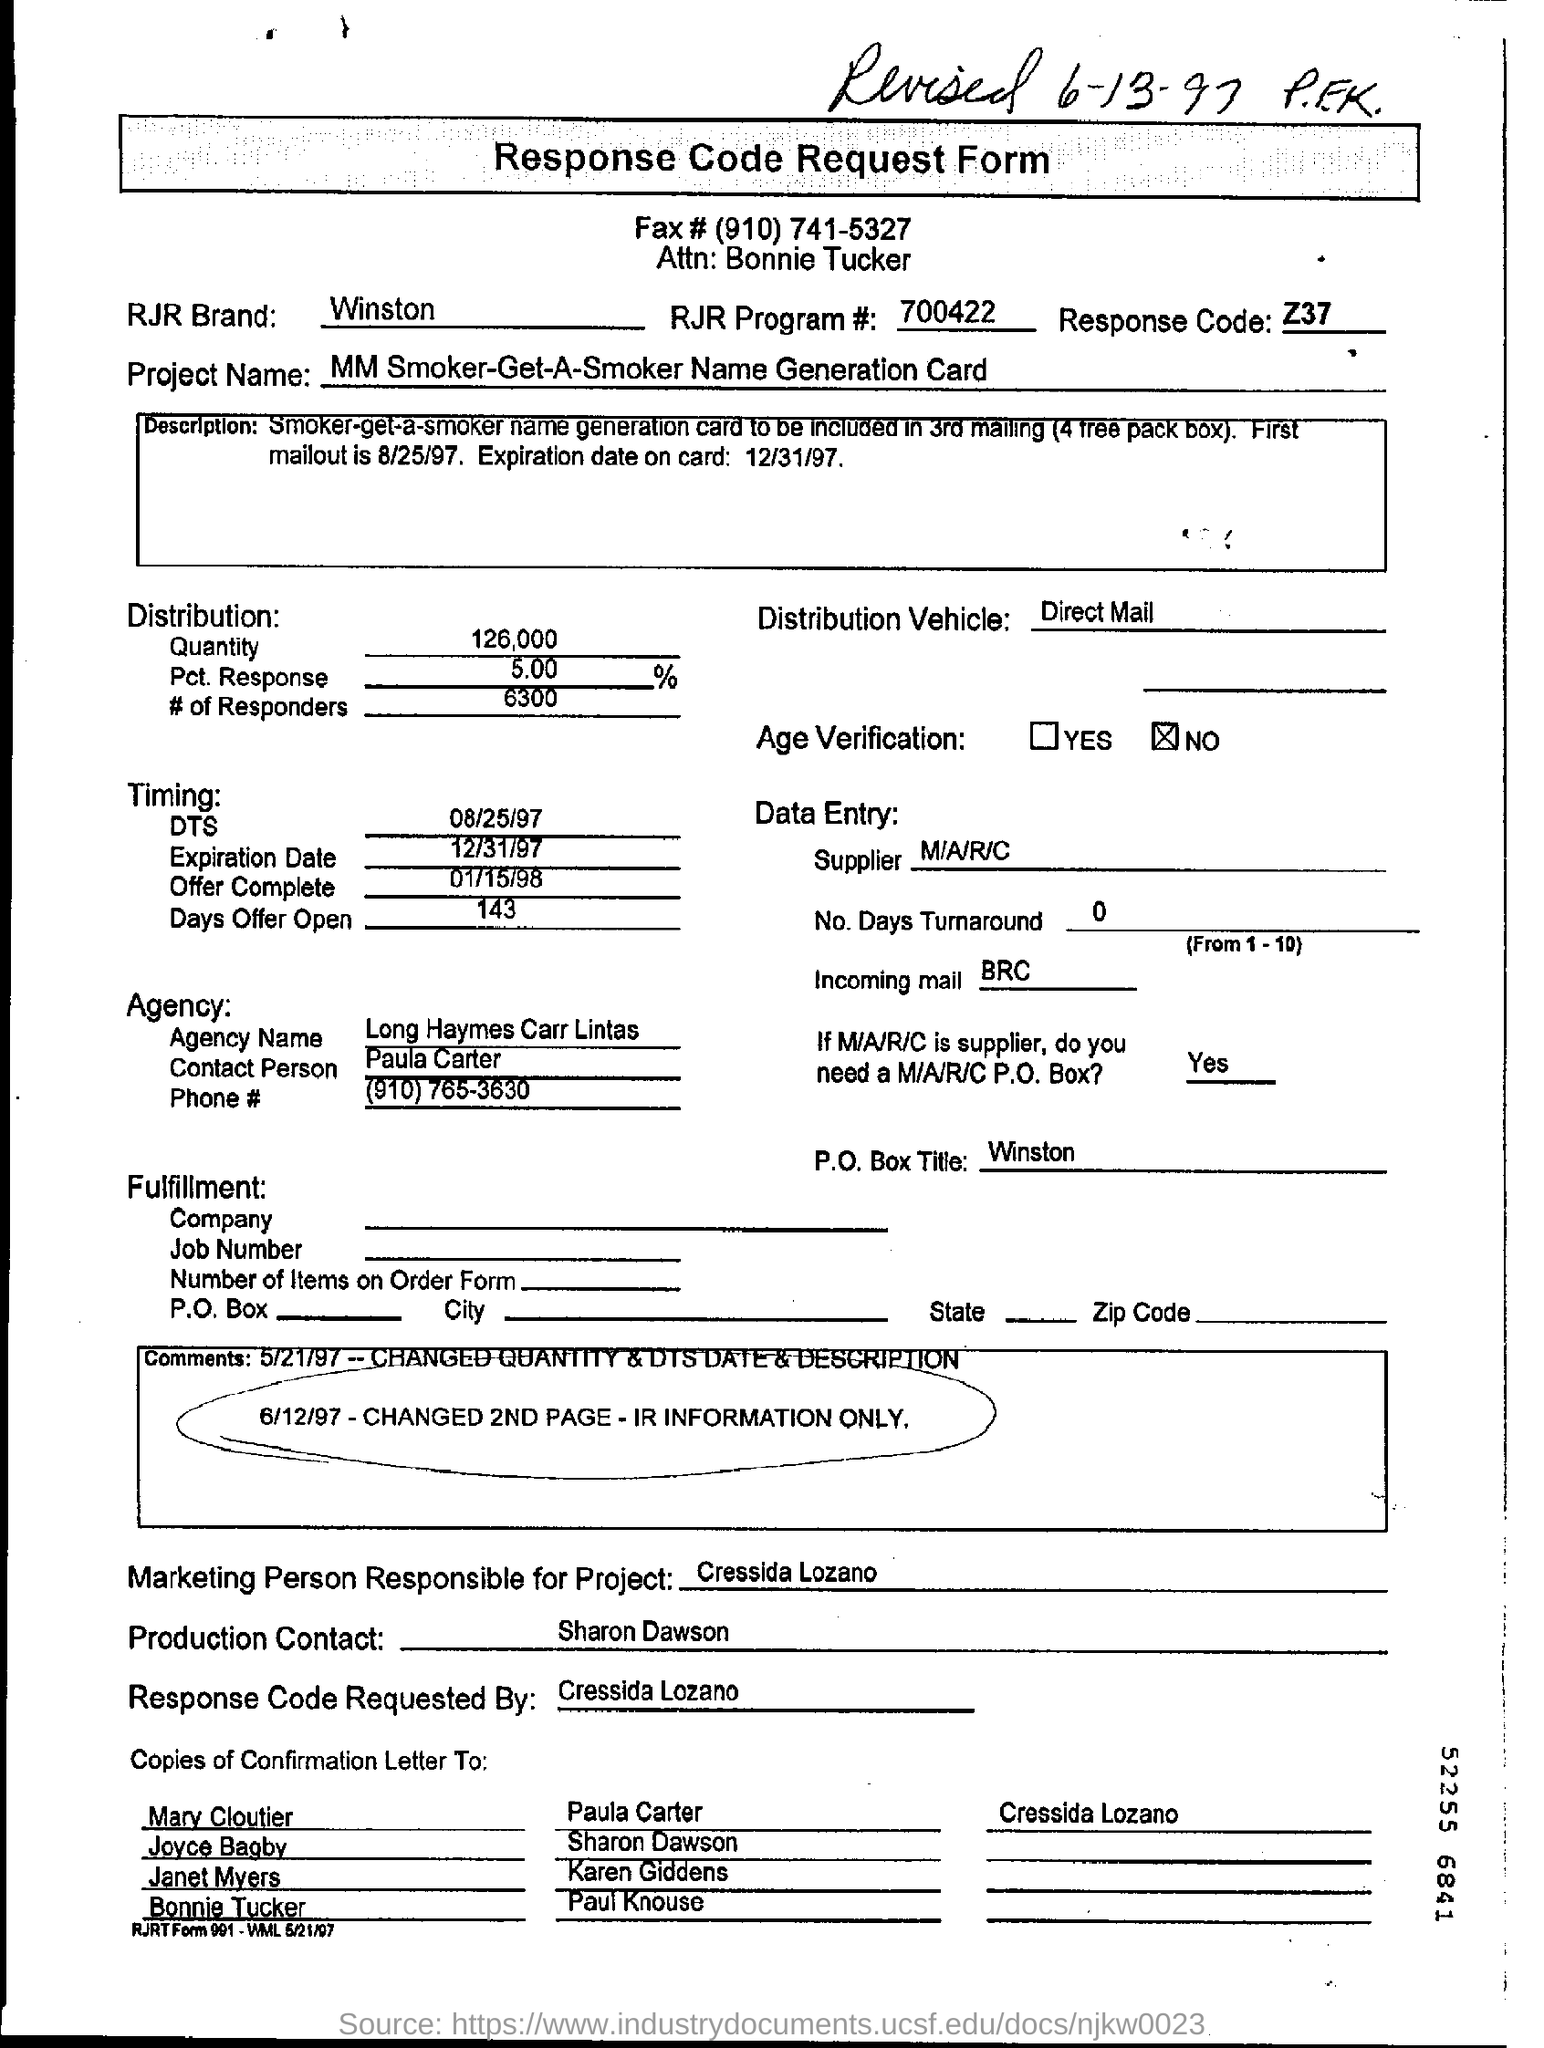Outline some significant characteristics in this image. The heading of the document is 'Response Code Request Form'. Winston is a brand of cigarettes produced by RJR Tobacco Company, known for its distinctive logo and marketing campaigns, which have made it one of the most recognizable brands in the tobacco industry. The response code is Z37.. The handwritten sentence at the top, revised on June 13, 1997, by P.E.K., states... 